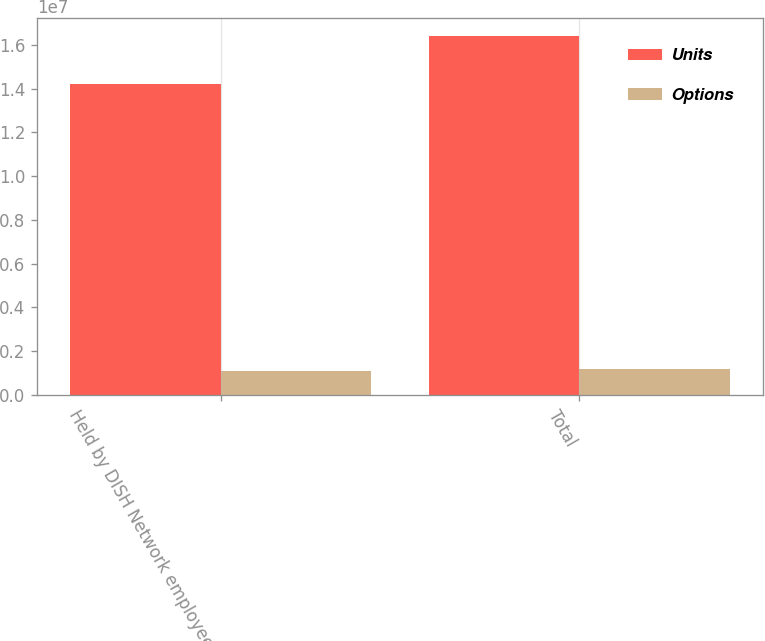Convert chart. <chart><loc_0><loc_0><loc_500><loc_500><stacked_bar_chart><ecel><fcel>Held by DISH Network employees<fcel>Total<nl><fcel>Units<fcel>1.42096e+07<fcel>1.63999e+07<nl><fcel>Options<fcel>1.09008e+06<fcel>1.18508e+06<nl></chart> 